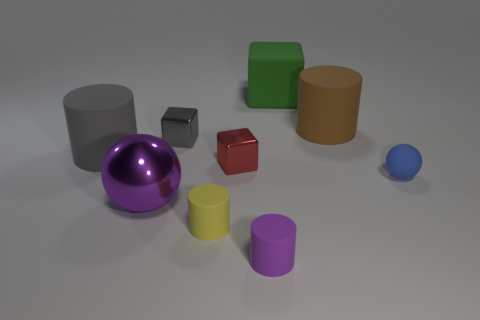What color is the other small rubber thing that is the same shape as the purple rubber object?
Your answer should be very brief. Yellow. How many big shiny things have the same color as the matte ball?
Provide a short and direct response. 0. Is the size of the gray cylinder the same as the red block?
Give a very brief answer. No. What material is the purple ball?
Provide a short and direct response. Metal. There is a cube that is made of the same material as the small purple object; what is its color?
Ensure brevity in your answer.  Green. Is the small gray block made of the same material as the sphere that is to the left of the brown matte object?
Offer a terse response. Yes. What number of small cyan blocks are the same material as the small blue ball?
Provide a short and direct response. 0. There is a tiny metallic object left of the red shiny cube; what shape is it?
Give a very brief answer. Cube. Is the material of the ball that is to the left of the small blue ball the same as the tiny red thing on the right side of the tiny yellow cylinder?
Give a very brief answer. Yes. Is there another tiny metallic thing that has the same shape as the tiny red shiny thing?
Your answer should be compact. Yes. 